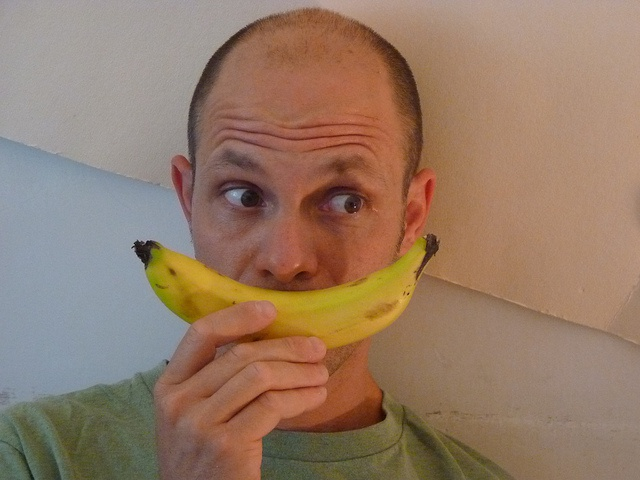Describe the objects in this image and their specific colors. I can see people in darkgray, brown, and maroon tones and banana in darkgray, olive, orange, and gray tones in this image. 